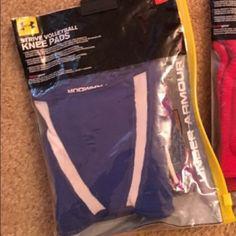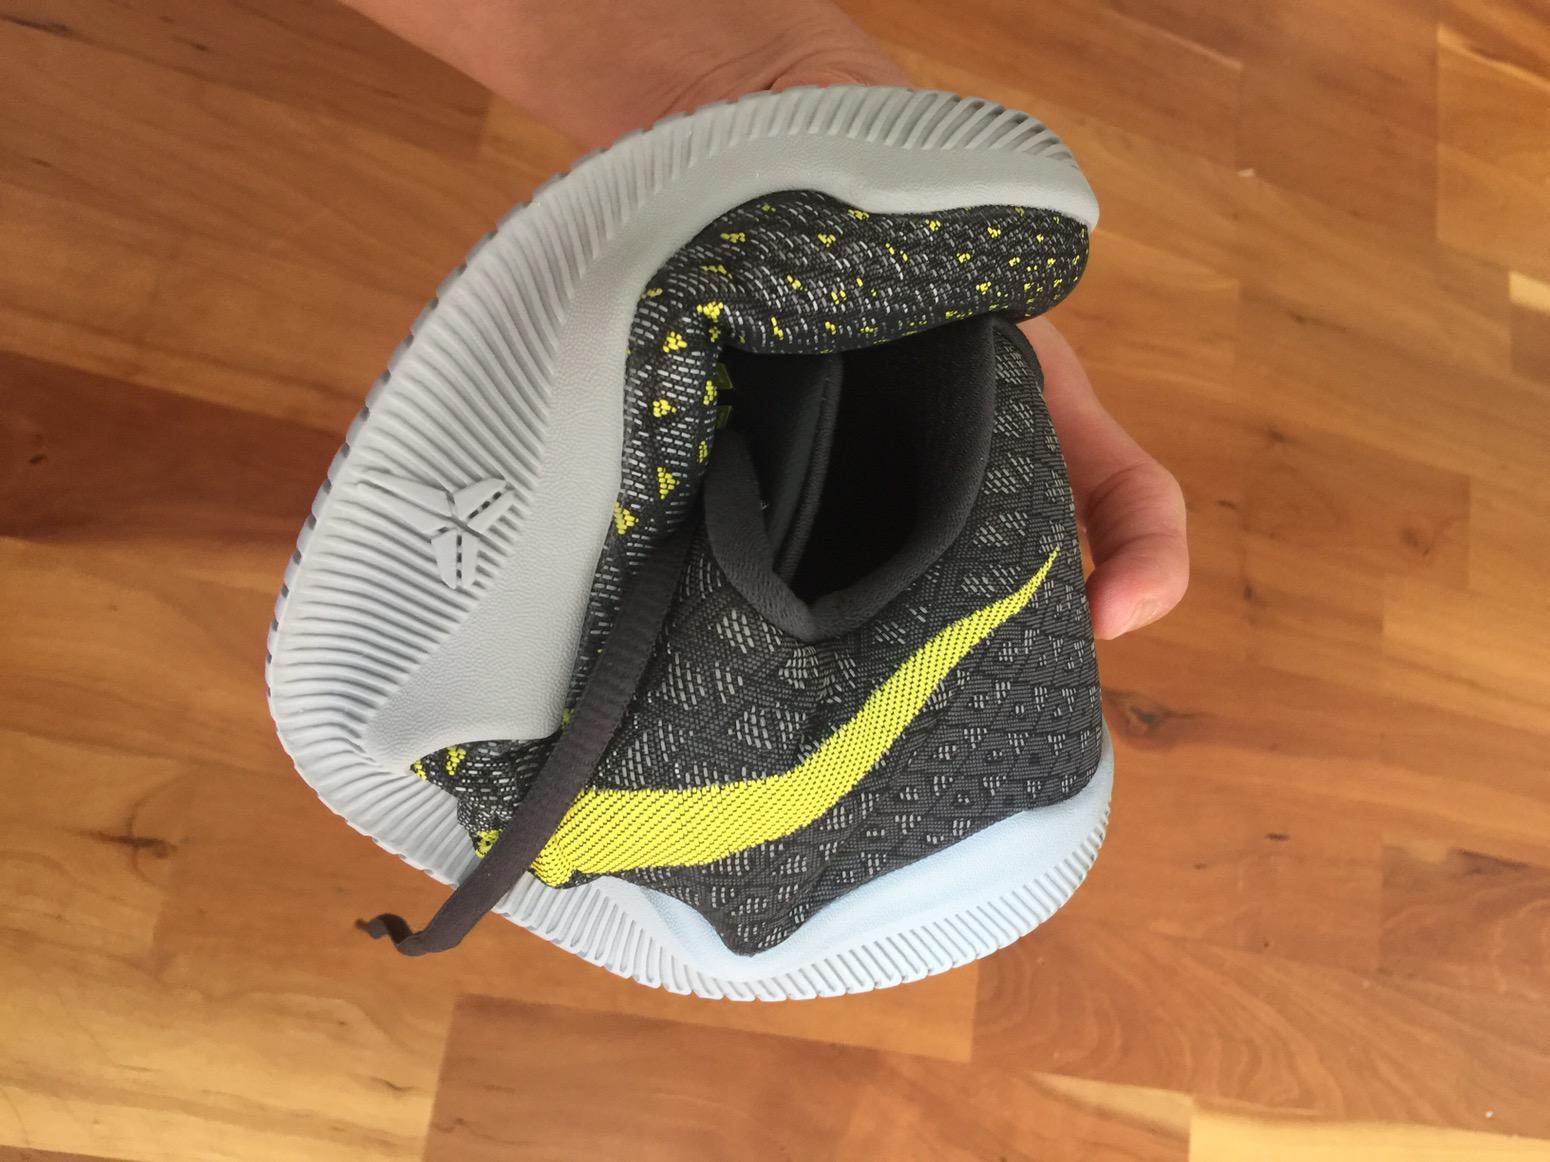The first image is the image on the left, the second image is the image on the right. Considering the images on both sides, is "All images show legs wearing kneepads." valid? Answer yes or no. No. The first image is the image on the left, the second image is the image on the right. Examine the images to the left and right. Is the description "At least one of the images does not contain the legs of a human." accurate? Answer yes or no. Yes. 